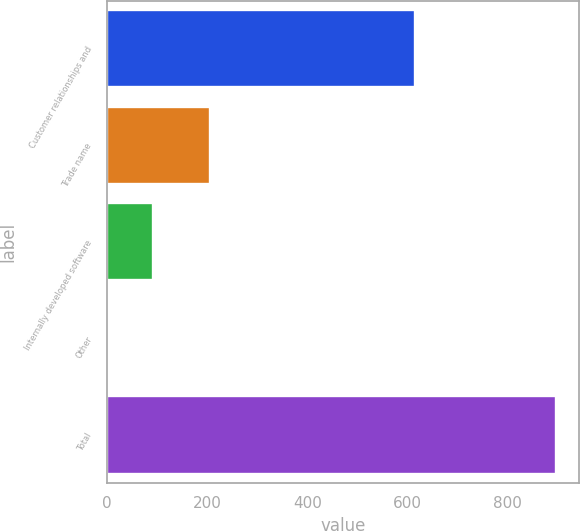<chart> <loc_0><loc_0><loc_500><loc_500><bar_chart><fcel>Customer relationships and<fcel>Trade name<fcel>Internally developed software<fcel>Other<fcel>Total<nl><fcel>616<fcel>205.9<fcel>91.59<fcel>2.1<fcel>897<nl></chart> 